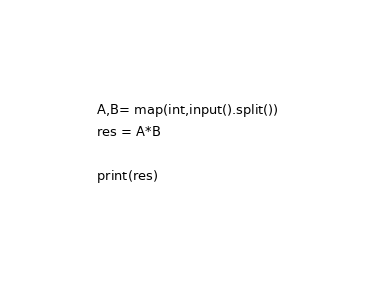Convert code to text. <code><loc_0><loc_0><loc_500><loc_500><_Python_>A,B= map(int,input().split())
res = A*B

print(res)</code> 